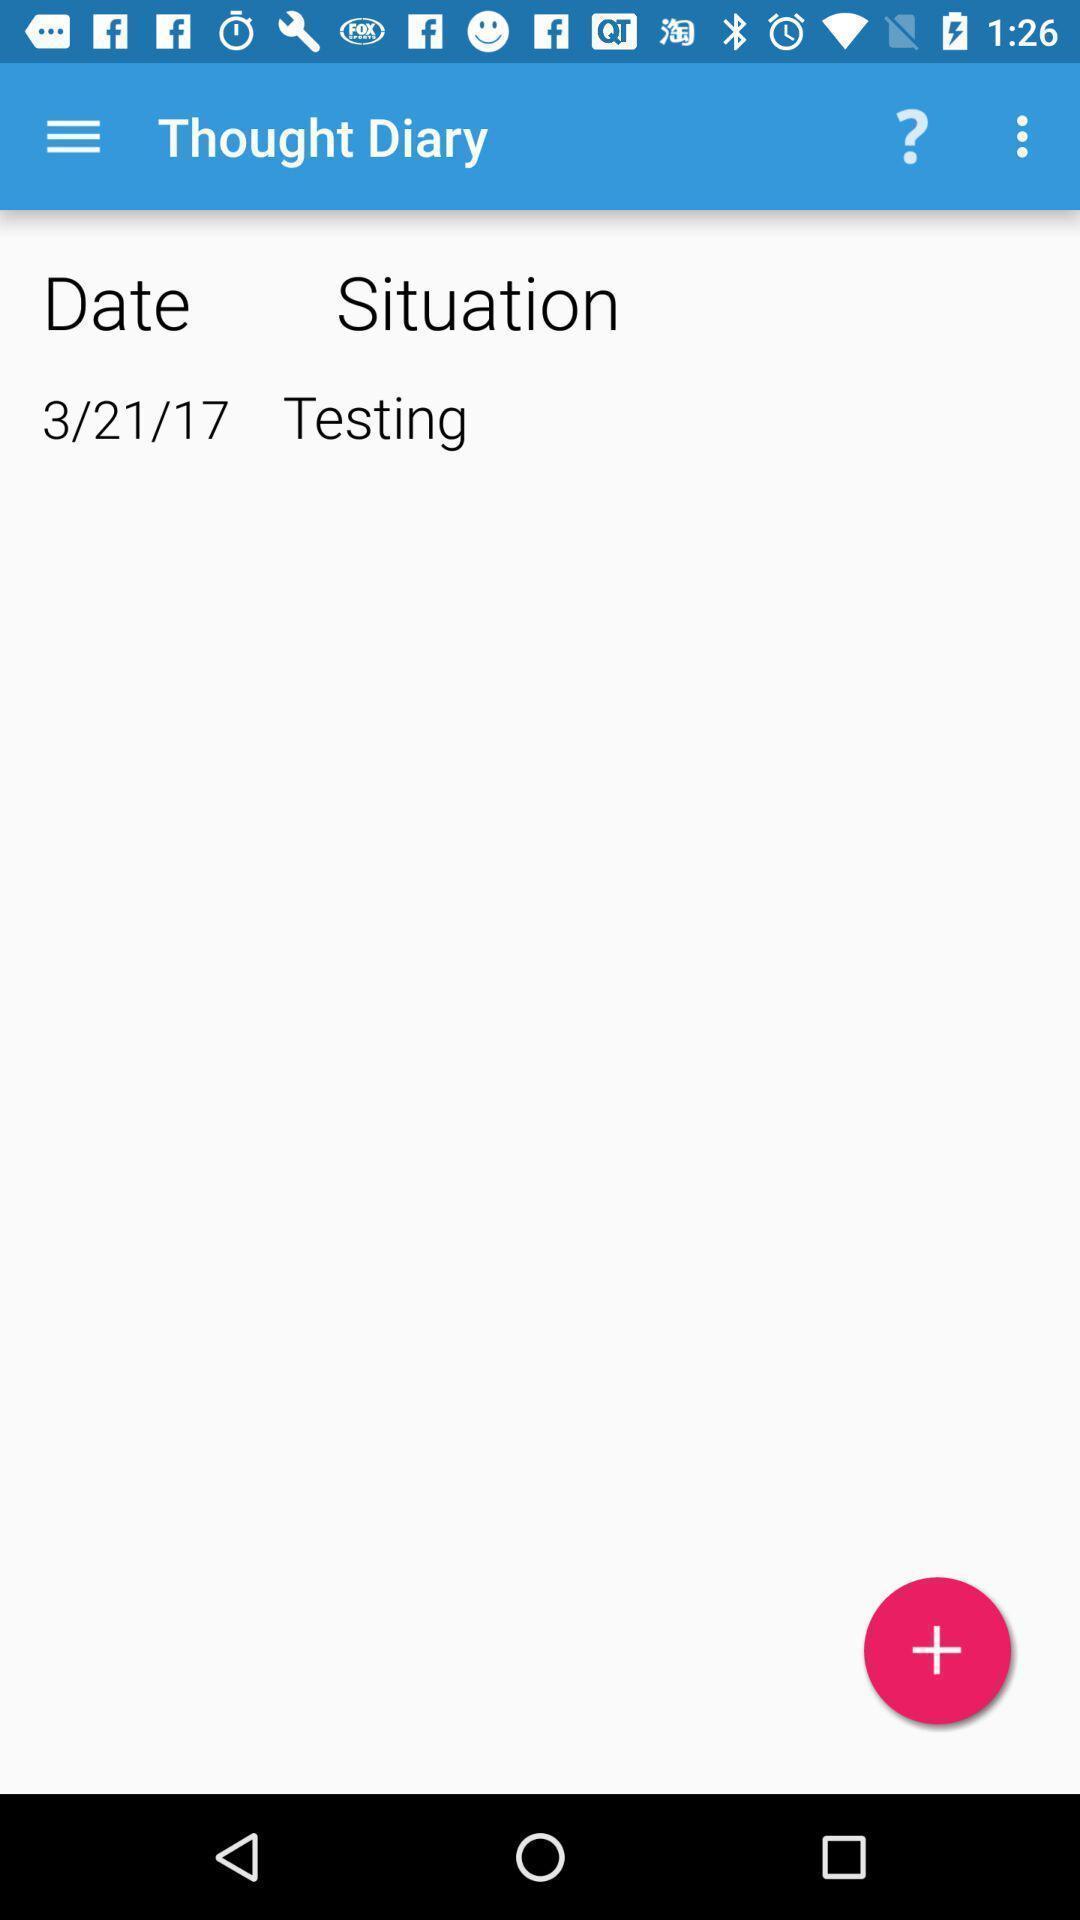Provide a detailed account of this screenshot. Screen showing a dairy entry. 